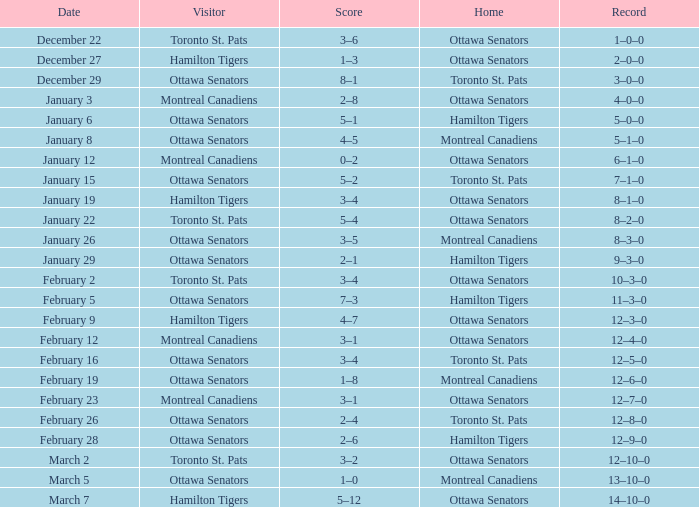Who was the home team when the vistor team was the Montreal Canadiens on February 12? Ottawa Senators. 